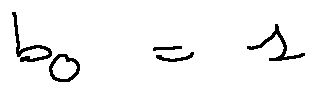<formula> <loc_0><loc_0><loc_500><loc_500>b _ { 0 } = 1</formula> 